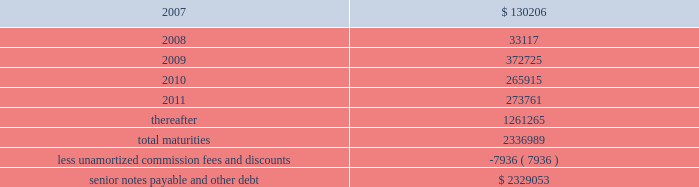Ventas , inc .
Notes to consolidated financial statements 2014 ( continued ) if we experience certain kinds of changes of control , the issuers must make an offer to repurchase the senior notes , in whole or in part , at a purchase price in cash equal to 101% ( 101 % ) of the principal amount of the senior notes , plus any accrued and unpaid interest to the date of purchase ; provided , however , that in the event moody 2019s and s&p have confirmed their ratings at ba3 or higher and bb- or higher on the senior notes and certain other conditions are met , this repurchase obligation will not apply .
Mortgages at december 31 , 2006 , we had outstanding 53 mortgage loans that we assumed in connection with various acquisitions .
Outstanding principal balances on these loans ranged from $ 0.4 million to $ 114.4 million as of december 31 , 2006 .
The loans bear interest at fixed rates ranging from 5.6% ( 5.6 % ) to 8.5% ( 8.5 % ) per annum , except with respect to eight loans with outstanding principal balances ranging from $ 0.4 million to $ 114.4 million , which bear interest at the lender 2019s variable rates , ranging from 3.6% ( 3.6 % ) to 8.5% ( 8.5 % ) per annum at of december 31 , 2006 .
The fixed rate debt bears interest at a weighted average annual rate of 7.06% ( 7.06 % ) and the variable rate debt bears interest at a weighted average annual rate of 5.61% ( 5.61 % ) as of december 31 , 2006 .
The loans had a weighted average maturity of eight years as of december 31 , 2006 .
The $ 114.4 variable mortgage debt was repaid in january 2007 .
Scheduled maturities of borrowing arrangements and other provisions as of december 31 , 2006 , our indebtedness has the following maturities ( in thousands ) : .
Certain provisions of our long-term debt contain covenants that limit our ability and the ability of certain of our subsidiaries to , among other things : ( i ) incur debt ; ( ii ) make certain dividends , distributions and investments ; ( iii ) enter into certain transactions ; ( iv ) merge , consolidate or transfer certain assets ; and ( v ) sell assets .
We and certain of our subsidiaries are also required to maintain total unencumbered assets of at least 150% ( 150 % ) of this group 2019s unsecured debt .
Derivatives and hedging in the normal course of business , we are exposed to the effect of interest rate changes .
We limit these risks by following established risk management policies and procedures including the use of derivatives .
For interest rate exposures , derivatives are used primarily to fix the rate on debt based on floating-rate indices and to manage the cost of borrowing obligations .
We currently have an interest rate swap to manage interest rate risk ( the 201cswap 201d ) .
We prohibit the use of derivative instruments for trading or speculative purposes .
Further , we have a policy of only entering into contracts with major financial institutions based upon their credit ratings and other factors .
When viewed in conjunction with the underlying and offsetting exposure that the derivative is designed to hedge , we do not anticipate any material adverse effect on our net income or financial position in the future from the use of derivatives. .
What was the percent of the 2008 maturities as a part of the total maturities? 
Rationale: the growth rate is the change from period to period divided by the original amount
Computations: (33117 / 2336989)
Answer: 0.01417. 